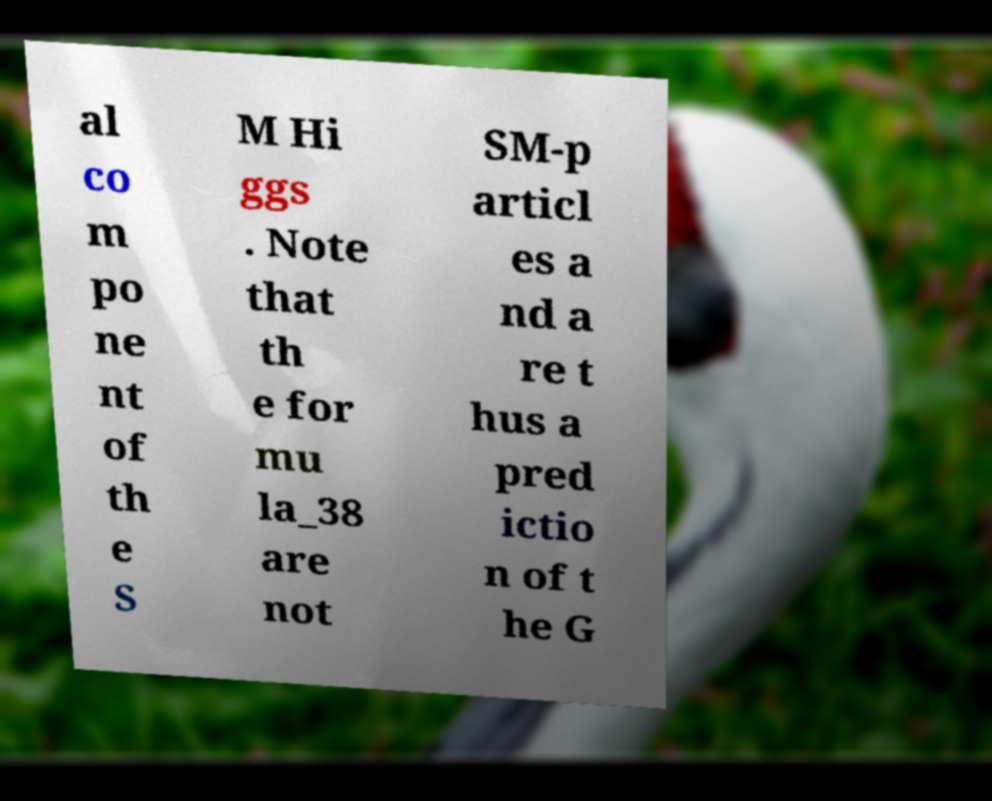What messages or text are displayed in this image? I need them in a readable, typed format. al co m po ne nt of th e S M Hi ggs . Note that th e for mu la_38 are not SM-p articl es a nd a re t hus a pred ictio n of t he G 